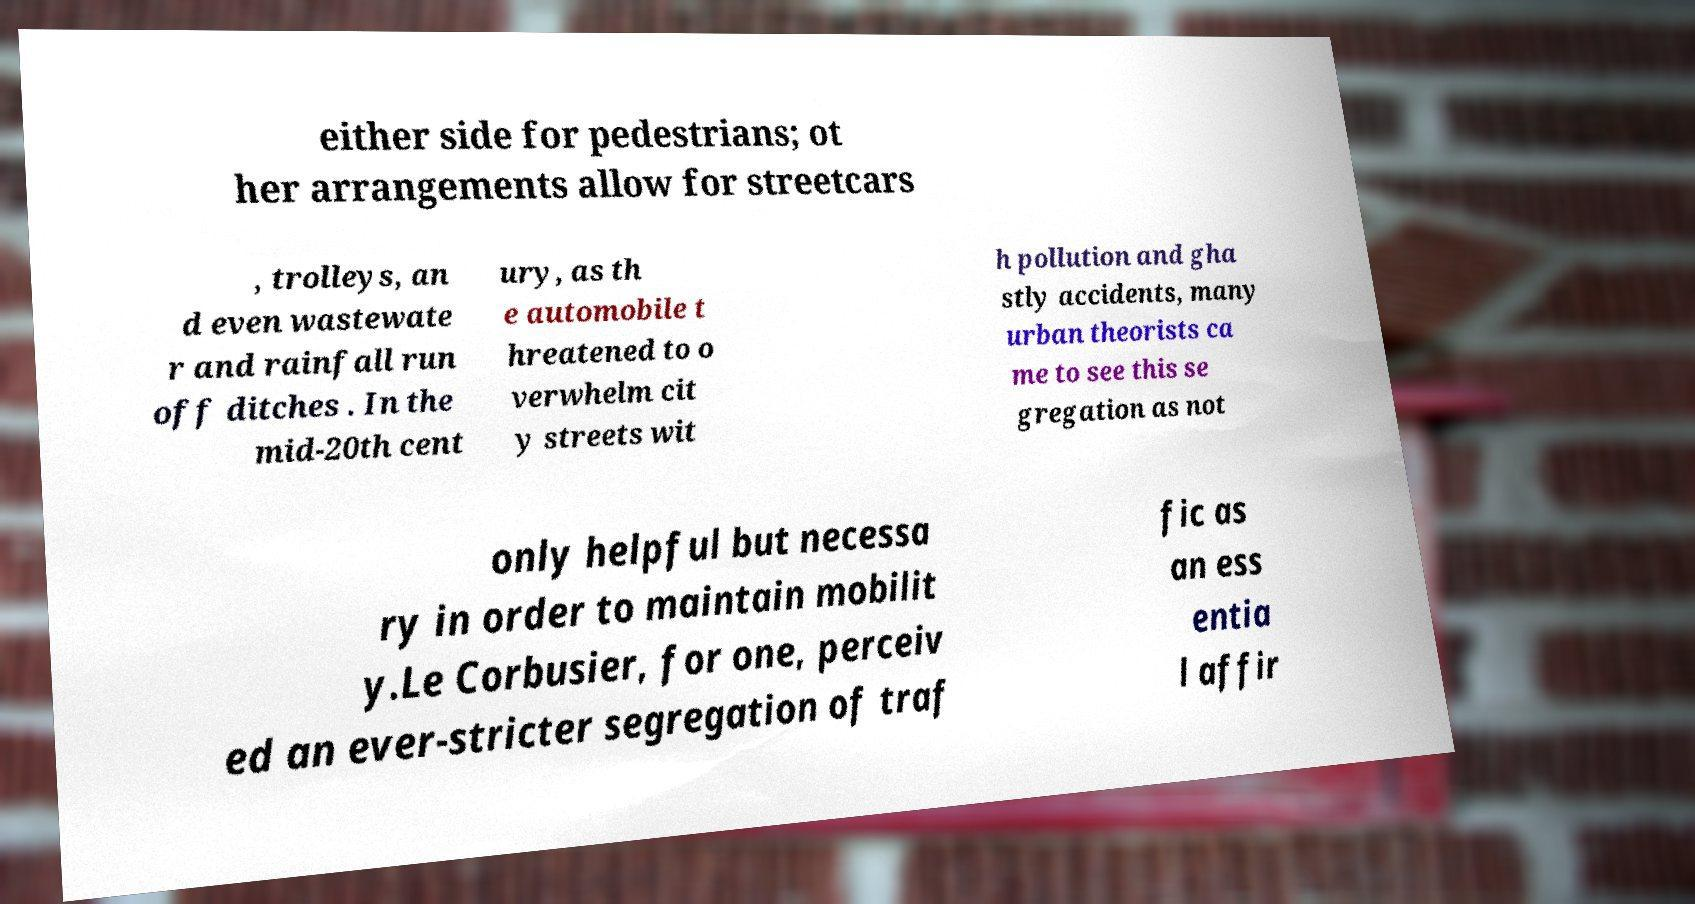Can you read and provide the text displayed in the image?This photo seems to have some interesting text. Can you extract and type it out for me? either side for pedestrians; ot her arrangements allow for streetcars , trolleys, an d even wastewate r and rainfall run off ditches . In the mid-20th cent ury, as th e automobile t hreatened to o verwhelm cit y streets wit h pollution and gha stly accidents, many urban theorists ca me to see this se gregation as not only helpful but necessa ry in order to maintain mobilit y.Le Corbusier, for one, perceiv ed an ever-stricter segregation of traf fic as an ess entia l affir 